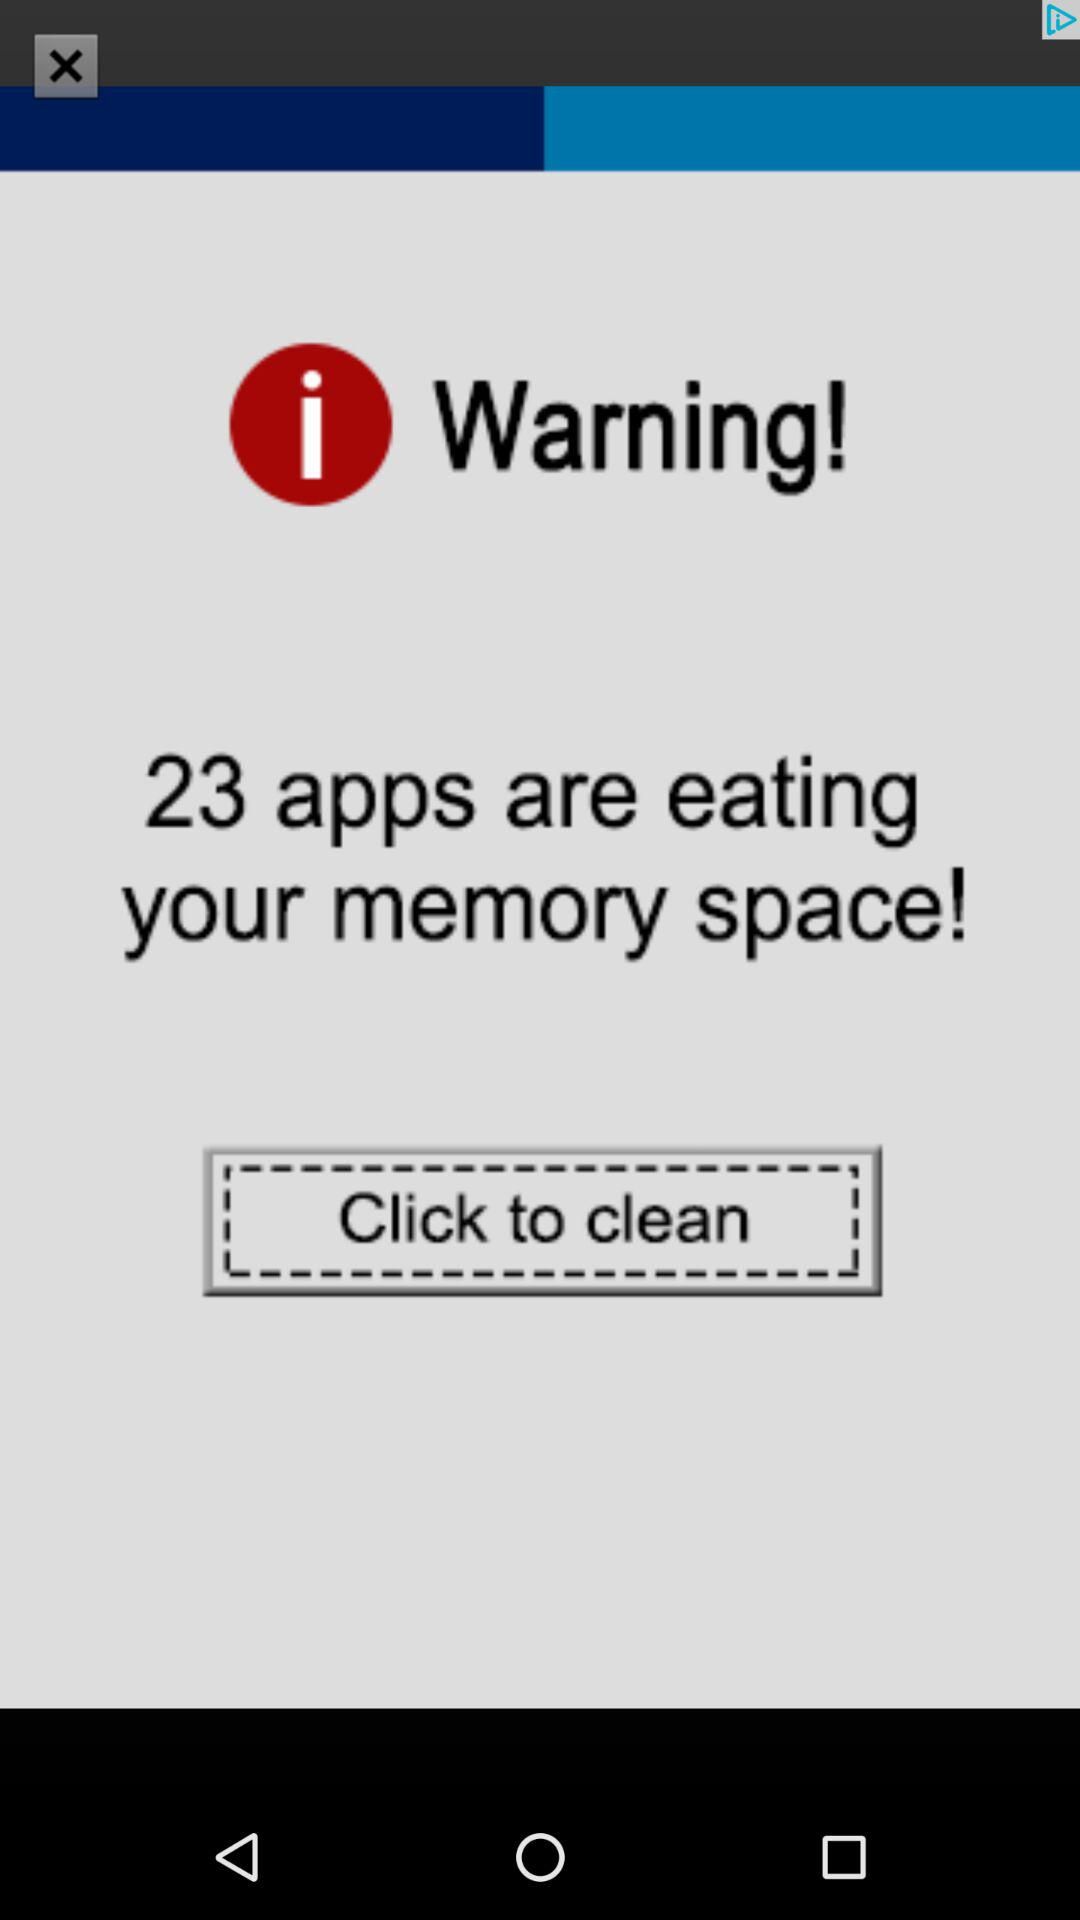How many apps are eating up my memory space?
Answer the question using a single word or phrase. 23 